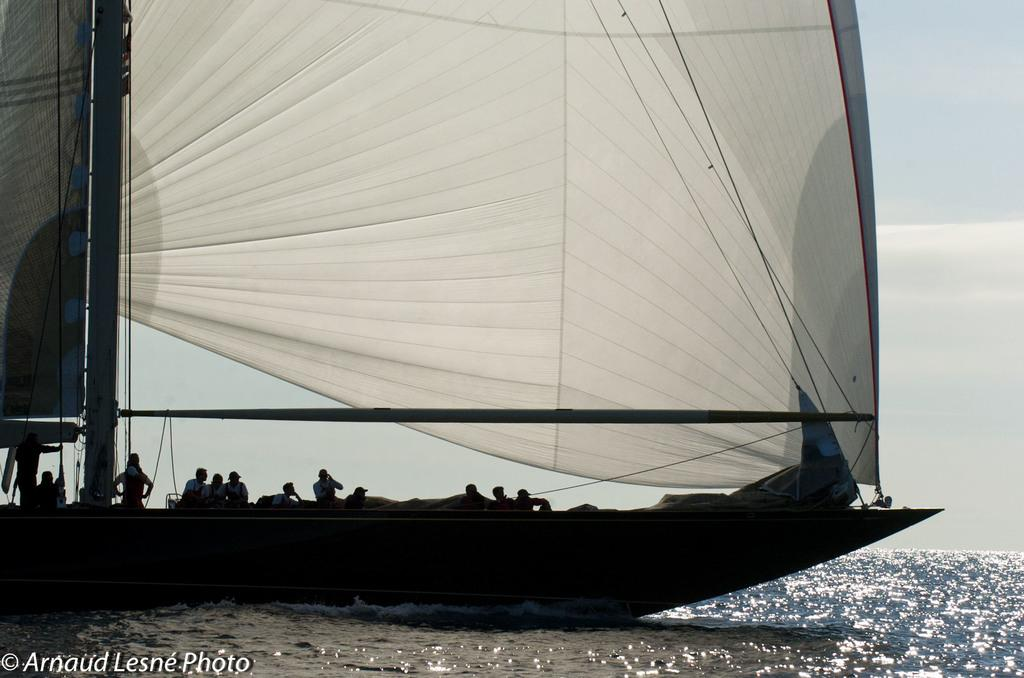What is the main subject of the image? The main subject of the image is a boat. Where is the boat located? The boat is on the sea. Are there any people on the boat? Yes, there are people on the boat. What feature does the boat have for propulsion? The boat has a sail. What can be seen in the background of the image? The sky is visible in the image. Is there any text present in the image? Yes, there is text in the bottom left corner of the image. Can you tell me how many combs are being used by the people on the boat? There is no information about combs in the image, so we cannot determine if any are being used. What type of flock is flying over the boat in the image? There are no birds or flocks visible in the image. 